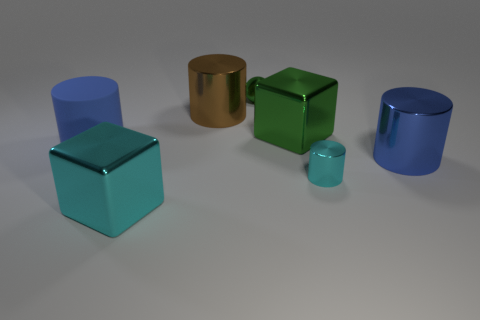What material is the big cube that is the same color as the metal ball?
Give a very brief answer. Metal. What number of big objects are either balls or blue metallic blocks?
Ensure brevity in your answer.  0. What is the shape of the green shiny thing to the right of the tiny sphere?
Offer a terse response. Cube. Is there a cylinder that has the same color as the small metallic sphere?
Make the answer very short. No. There is a cyan object to the right of the big cyan block; is it the same size as the blue object that is to the right of the big blue rubber cylinder?
Give a very brief answer. No. Are there more big blue objects that are behind the small cyan shiny thing than shiny balls that are right of the blue shiny cylinder?
Your answer should be compact. Yes. Is there a big green object made of the same material as the cyan block?
Your answer should be very brief. Yes. What material is the thing that is both right of the large brown shiny cylinder and behind the green cube?
Give a very brief answer. Metal. What color is the large rubber thing?
Your response must be concise. Blue. How many big cyan things have the same shape as the big green object?
Your response must be concise. 1. 